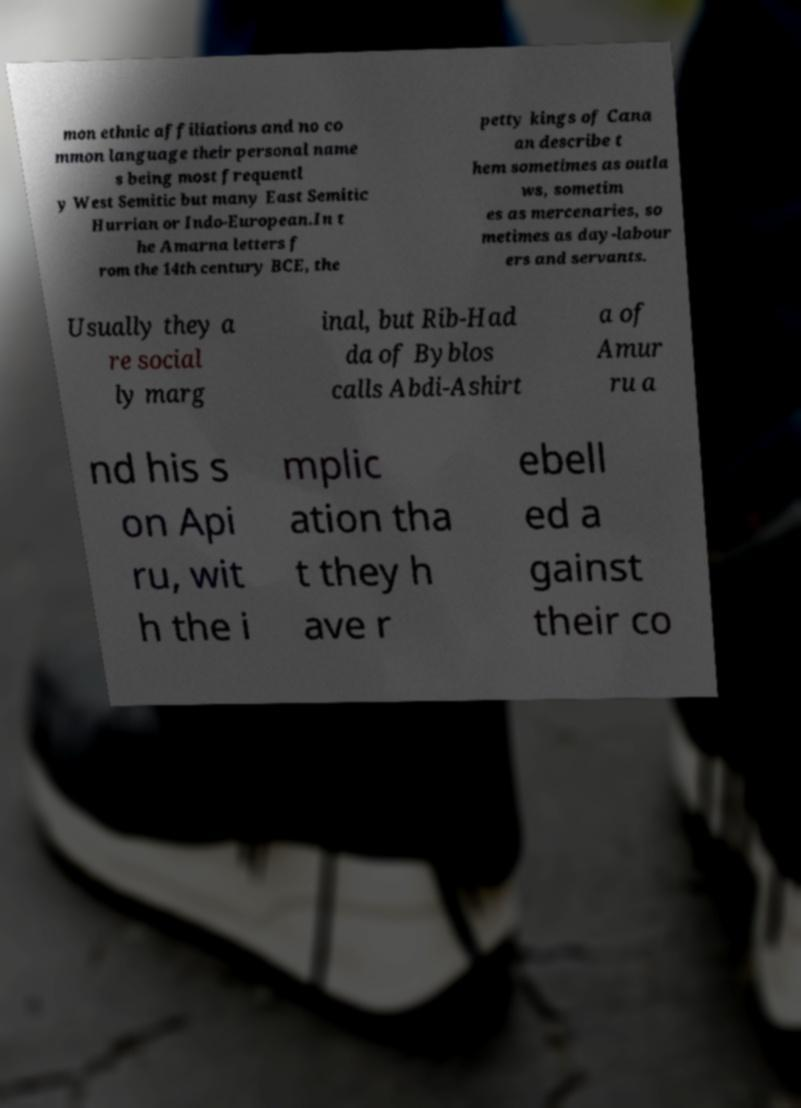Could you extract and type out the text from this image? mon ethnic affiliations and no co mmon language their personal name s being most frequentl y West Semitic but many East Semitic Hurrian or Indo-European.In t he Amarna letters f rom the 14th century BCE, the petty kings of Cana an describe t hem sometimes as outla ws, sometim es as mercenaries, so metimes as day-labour ers and servants. Usually they a re social ly marg inal, but Rib-Had da of Byblos calls Abdi-Ashirt a of Amur ru a nd his s on Api ru, wit h the i mplic ation tha t they h ave r ebell ed a gainst their co 